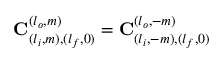Convert formula to latex. <formula><loc_0><loc_0><loc_500><loc_500>C _ { ( l _ { i } , m ) , ( l _ { f } , 0 ) } ^ { ( l _ { o } , m ) } = C _ { ( l _ { i } , - m ) , ( l _ { f } , 0 ) } ^ { ( l _ { o } , - m ) }</formula> 